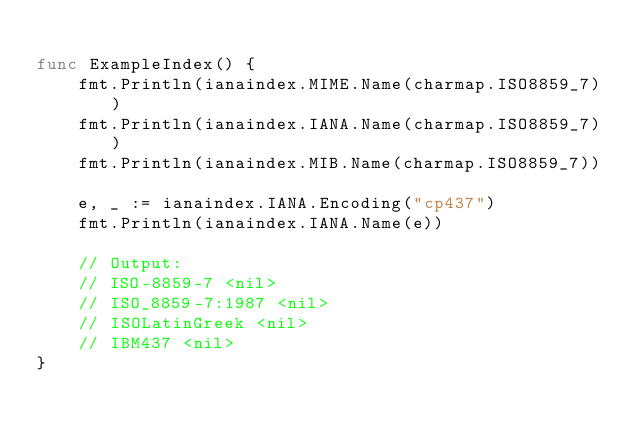Convert code to text. <code><loc_0><loc_0><loc_500><loc_500><_Go_>
func ExampleIndex() {
	fmt.Println(ianaindex.MIME.Name(charmap.ISO8859_7))
	fmt.Println(ianaindex.IANA.Name(charmap.ISO8859_7))
	fmt.Println(ianaindex.MIB.Name(charmap.ISO8859_7))

	e, _ := ianaindex.IANA.Encoding("cp437")
	fmt.Println(ianaindex.IANA.Name(e))

	// Output:
	// ISO-8859-7 <nil>
	// ISO_8859-7:1987 <nil>
	// ISOLatinGreek <nil>
	// IBM437 <nil>
}
</code> 